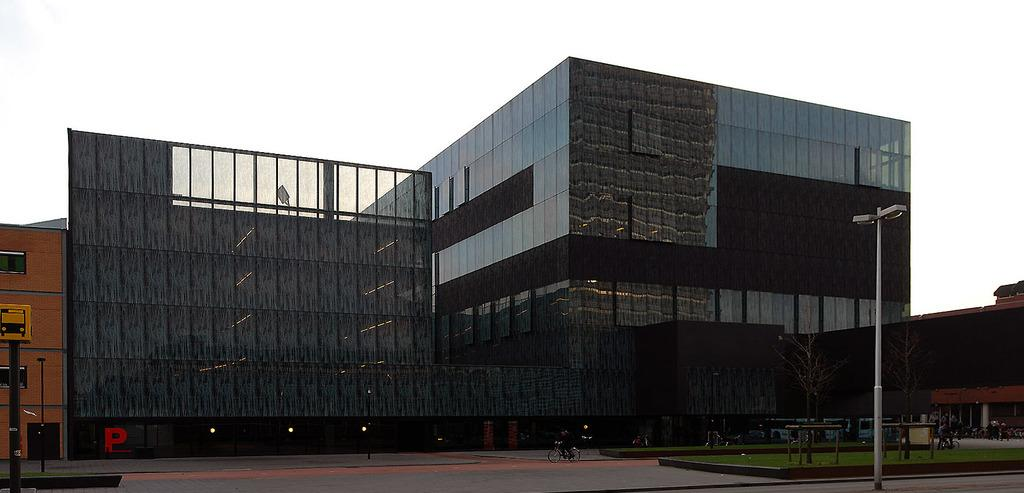What type of structure can be seen in the image? There is a building in the image. What natural elements are present in the image? There are trees in the image. What man-made objects can be seen in the image? Vehicles, light poles, and a signboard are visible in the image. Are there any living beings in the image? Yes, there are people in the image. What can be seen in the background of the image? The sky is visible in the background of the image. What is the texture of the mist in the image? There is no mist present in the image, so it is not possible to describe its texture. 